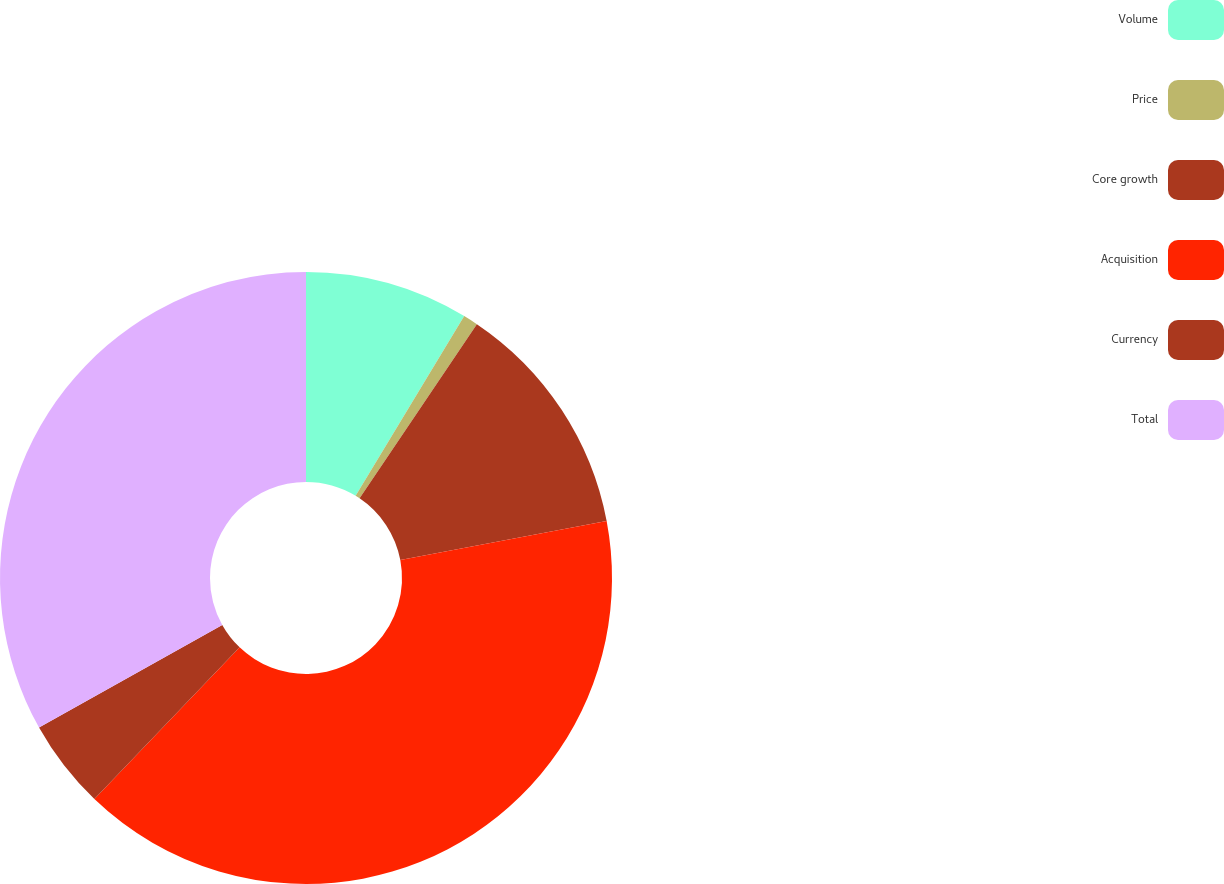<chart> <loc_0><loc_0><loc_500><loc_500><pie_chart><fcel>Volume<fcel>Price<fcel>Core growth<fcel>Acquisition<fcel>Currency<fcel>Total<nl><fcel>8.65%<fcel>0.78%<fcel>12.59%<fcel>40.14%<fcel>4.72%<fcel>33.13%<nl></chart> 